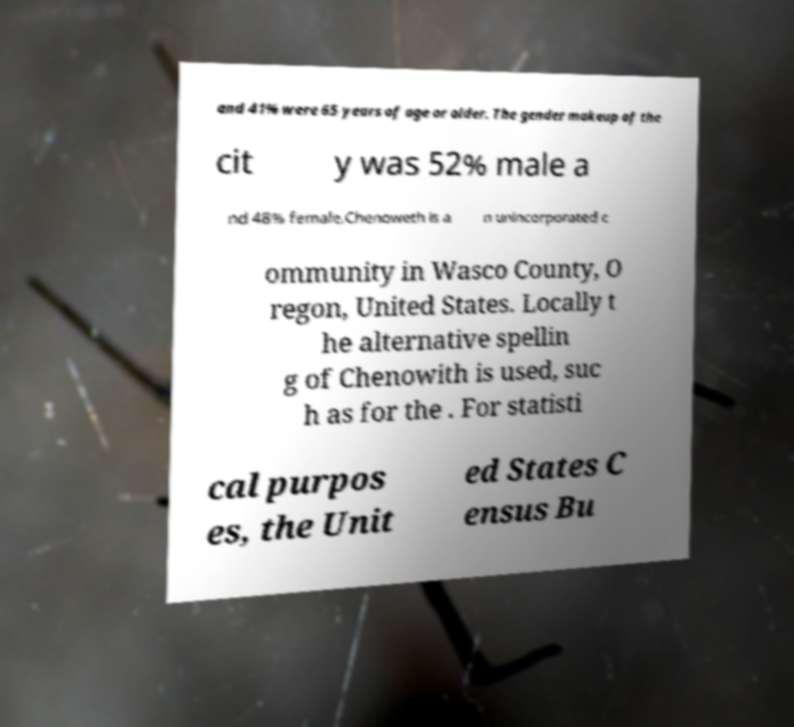Could you assist in decoding the text presented in this image and type it out clearly? and 41% were 65 years of age or older. The gender makeup of the cit y was 52% male a nd 48% female.Chenoweth is a n unincorporated c ommunity in Wasco County, O regon, United States. Locally t he alternative spellin g of Chenowith is used, suc h as for the . For statisti cal purpos es, the Unit ed States C ensus Bu 